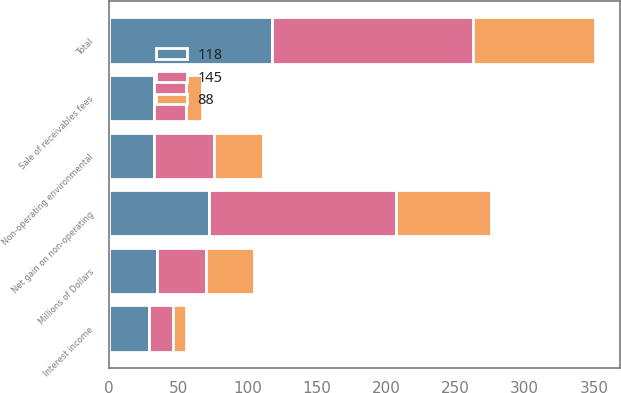Convert chart to OTSL. <chart><loc_0><loc_0><loc_500><loc_500><stacked_bar_chart><ecel><fcel>Millions of Dollars<fcel>Net gain on non-operating<fcel>Interest income<fcel>Sale of receivables fees<fcel>Non-operating environmental<fcel>Total<nl><fcel>118<fcel>35<fcel>72<fcel>29<fcel>33<fcel>33<fcel>118<nl><fcel>145<fcel>35<fcel>135<fcel>17<fcel>23<fcel>43<fcel>145<nl><fcel>88<fcel>35<fcel>69<fcel>10<fcel>11<fcel>35<fcel>88<nl></chart> 